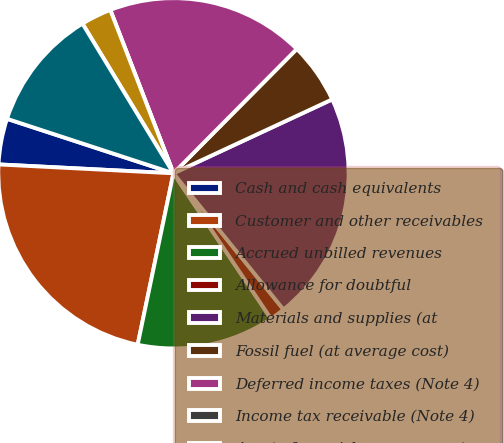Convert chart to OTSL. <chart><loc_0><loc_0><loc_500><loc_500><pie_chart><fcel>Cash and cash equivalents<fcel>Customer and other receivables<fcel>Accrued unbilled revenues<fcel>Allowance for doubtful<fcel>Materials and supplies (at<fcel>Fossil fuel (at average cost)<fcel>Deferred income taxes (Note 4)<fcel>Income tax receivable (Note 4)<fcel>Assets from risk management<fcel>Deferred fuel and purchased<nl><fcel>4.23%<fcel>22.53%<fcel>12.68%<fcel>1.41%<fcel>21.12%<fcel>5.63%<fcel>18.31%<fcel>0.0%<fcel>2.82%<fcel>11.27%<nl></chart> 